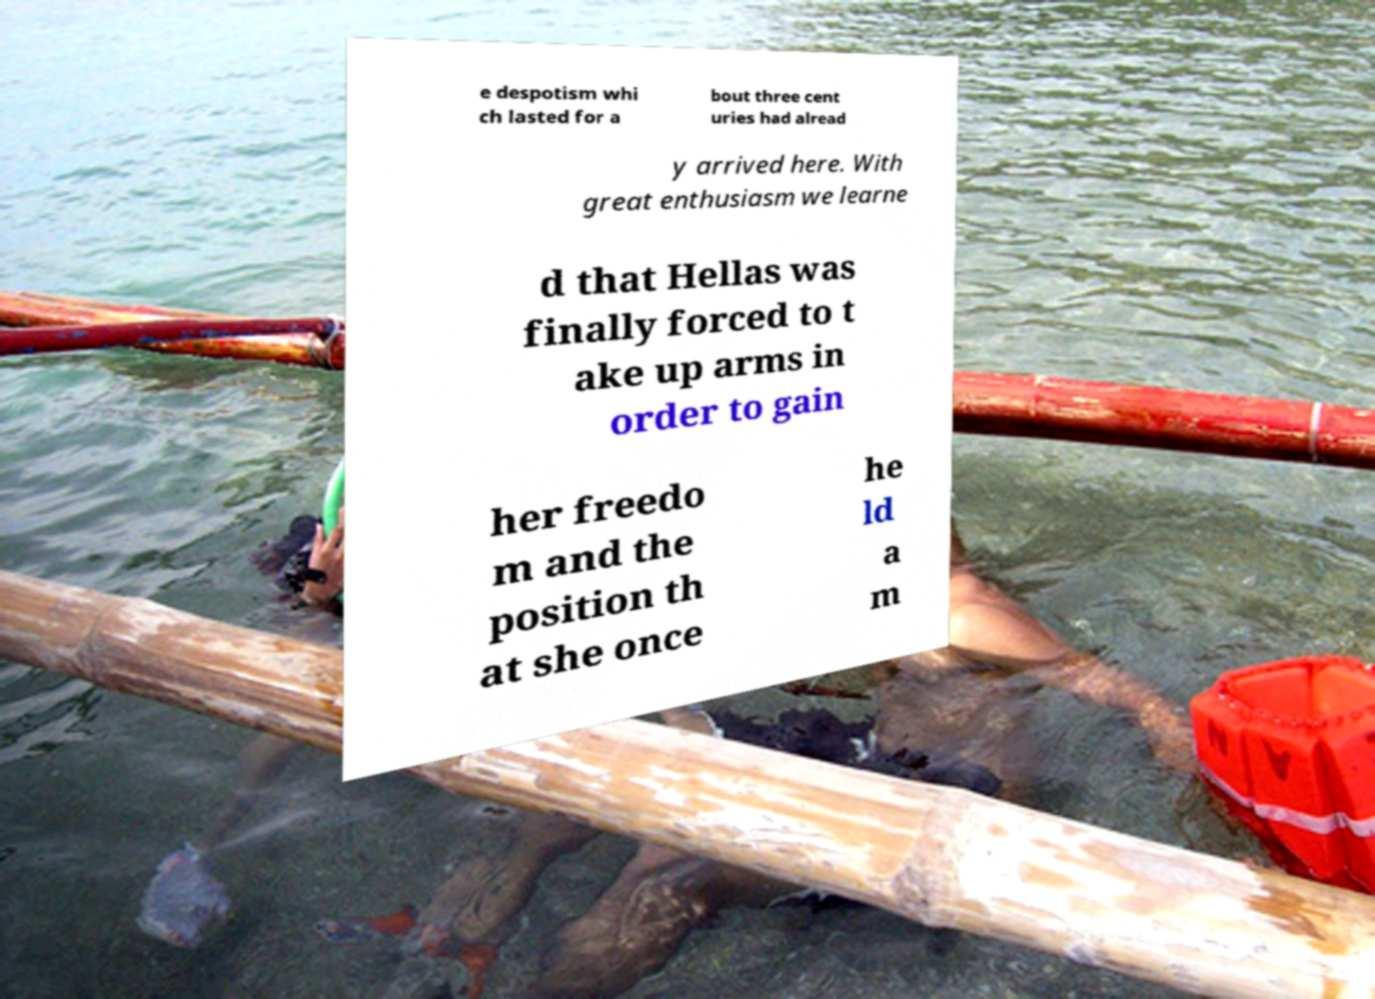Could you assist in decoding the text presented in this image and type it out clearly? e despotism whi ch lasted for a bout three cent uries had alread y arrived here. With great enthusiasm we learne d that Hellas was finally forced to t ake up arms in order to gain her freedo m and the position th at she once he ld a m 